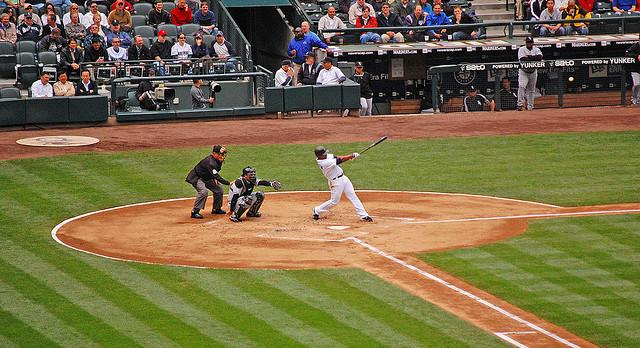Which wood used to make baseball bat? maple 